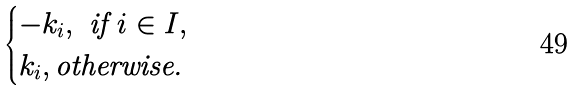<formula> <loc_0><loc_0><loc_500><loc_500>\begin{cases} - k _ { i } , \text { if } i \in I , \\ k _ { i } , \text {otherwise. } \end{cases}</formula> 